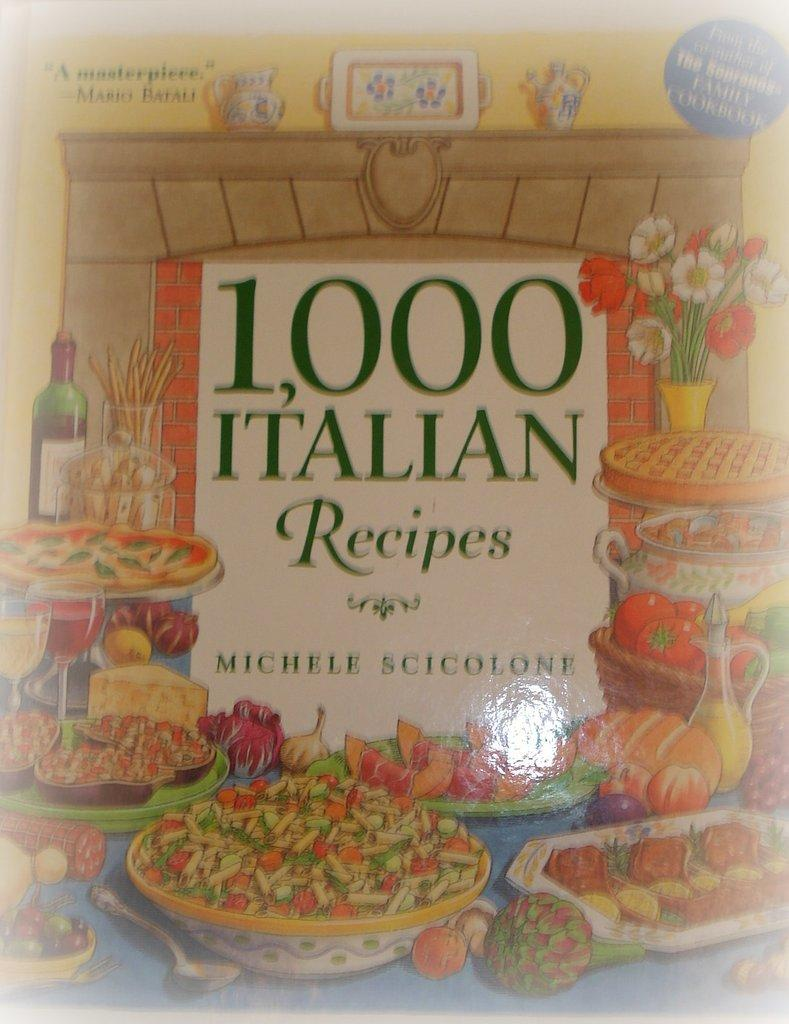Provide a one-sentence caption for the provided image. A cookbook by Michele Scicolone claims to have 1,000 Italian recipes in it. 